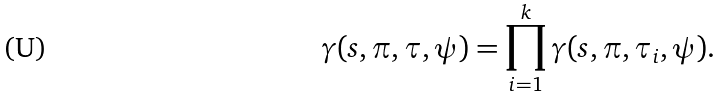Convert formula to latex. <formula><loc_0><loc_0><loc_500><loc_500>\gamma ( s , \pi , \tau , \psi ) = \prod _ { i = 1 } ^ { k } \gamma ( s , \pi , \tau _ { i } , \psi ) .</formula> 